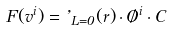Convert formula to latex. <formula><loc_0><loc_0><loc_500><loc_500>F ( v ^ { i } ) = \varphi _ { L = 0 } ( r ) \cdot \chi ^ { i } \cdot C</formula> 